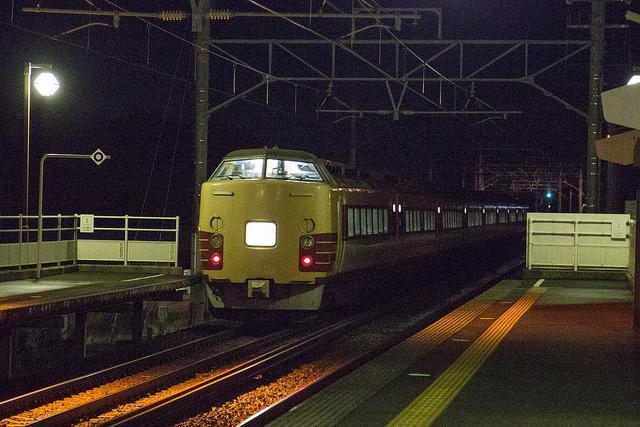How many trains are there?
Give a very brief answer. 1. 